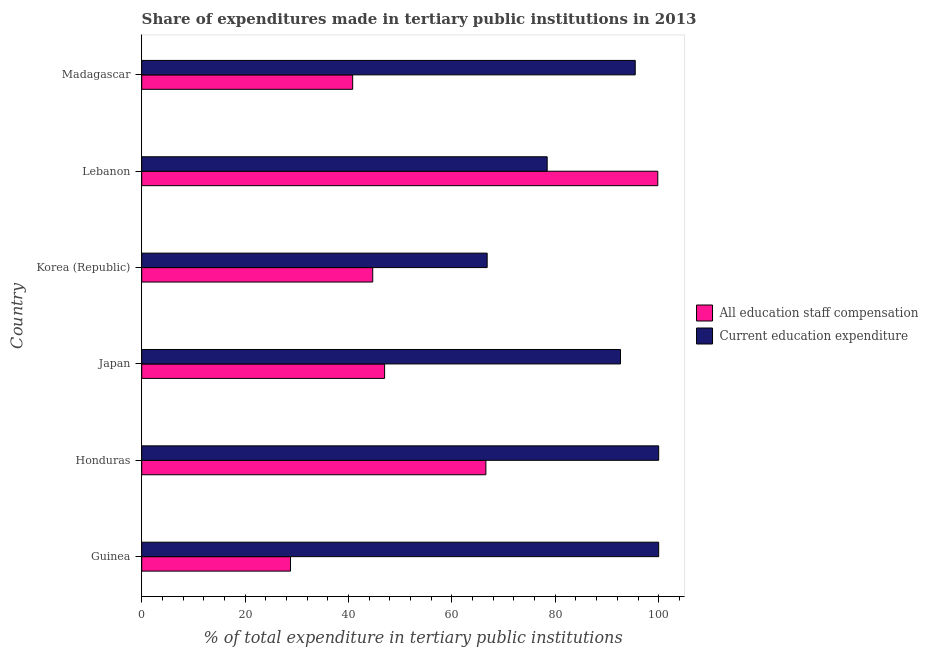How many groups of bars are there?
Offer a terse response. 6. Are the number of bars per tick equal to the number of legend labels?
Provide a succinct answer. Yes. Are the number of bars on each tick of the Y-axis equal?
Provide a short and direct response. Yes. How many bars are there on the 1st tick from the top?
Offer a very short reply. 2. What is the label of the 1st group of bars from the top?
Make the answer very short. Madagascar. In how many cases, is the number of bars for a given country not equal to the number of legend labels?
Your answer should be compact. 0. What is the expenditure in education in Korea (Republic)?
Provide a succinct answer. 66.82. Across all countries, what is the maximum expenditure in staff compensation?
Make the answer very short. 99.83. Across all countries, what is the minimum expenditure in education?
Offer a terse response. 66.82. In which country was the expenditure in education maximum?
Your response must be concise. Guinea. In which country was the expenditure in staff compensation minimum?
Make the answer very short. Guinea. What is the total expenditure in education in the graph?
Give a very brief answer. 533.34. What is the difference between the expenditure in education in Guinea and that in Japan?
Provide a short and direct response. 7.38. What is the difference between the expenditure in education in Madagascar and the expenditure in staff compensation in Guinea?
Provide a succinct answer. 66.68. What is the average expenditure in education per country?
Offer a terse response. 88.89. What is the difference between the expenditure in education and expenditure in staff compensation in Honduras?
Make the answer very short. 33.43. In how many countries, is the expenditure in education greater than 8 %?
Your answer should be compact. 6. What is the ratio of the expenditure in education in Japan to that in Lebanon?
Make the answer very short. 1.18. What is the difference between the highest and the second highest expenditure in education?
Provide a succinct answer. 0. What is the difference between the highest and the lowest expenditure in staff compensation?
Keep it short and to the point. 71.05. Is the sum of the expenditure in staff compensation in Lebanon and Madagascar greater than the maximum expenditure in education across all countries?
Provide a short and direct response. Yes. What does the 2nd bar from the top in Honduras represents?
Offer a terse response. All education staff compensation. What does the 1st bar from the bottom in Madagascar represents?
Your answer should be very brief. All education staff compensation. How many countries are there in the graph?
Offer a very short reply. 6. Does the graph contain grids?
Provide a short and direct response. No. What is the title of the graph?
Offer a terse response. Share of expenditures made in tertiary public institutions in 2013. What is the label or title of the X-axis?
Ensure brevity in your answer.  % of total expenditure in tertiary public institutions. What is the label or title of the Y-axis?
Provide a short and direct response. Country. What is the % of total expenditure in tertiary public institutions in All education staff compensation in Guinea?
Give a very brief answer. 28.78. What is the % of total expenditure in tertiary public institutions in All education staff compensation in Honduras?
Offer a very short reply. 66.57. What is the % of total expenditure in tertiary public institutions of Current education expenditure in Honduras?
Your response must be concise. 100. What is the % of total expenditure in tertiary public institutions in All education staff compensation in Japan?
Offer a terse response. 46.98. What is the % of total expenditure in tertiary public institutions of Current education expenditure in Japan?
Make the answer very short. 92.62. What is the % of total expenditure in tertiary public institutions of All education staff compensation in Korea (Republic)?
Give a very brief answer. 44.69. What is the % of total expenditure in tertiary public institutions of Current education expenditure in Korea (Republic)?
Provide a succinct answer. 66.82. What is the % of total expenditure in tertiary public institutions of All education staff compensation in Lebanon?
Offer a very short reply. 99.83. What is the % of total expenditure in tertiary public institutions of Current education expenditure in Lebanon?
Your answer should be compact. 78.43. What is the % of total expenditure in tertiary public institutions in All education staff compensation in Madagascar?
Your answer should be very brief. 40.81. What is the % of total expenditure in tertiary public institutions in Current education expenditure in Madagascar?
Give a very brief answer. 95.47. Across all countries, what is the maximum % of total expenditure in tertiary public institutions in All education staff compensation?
Ensure brevity in your answer.  99.83. Across all countries, what is the minimum % of total expenditure in tertiary public institutions of All education staff compensation?
Keep it short and to the point. 28.78. Across all countries, what is the minimum % of total expenditure in tertiary public institutions of Current education expenditure?
Keep it short and to the point. 66.82. What is the total % of total expenditure in tertiary public institutions in All education staff compensation in the graph?
Provide a succinct answer. 327.66. What is the total % of total expenditure in tertiary public institutions of Current education expenditure in the graph?
Offer a terse response. 533.34. What is the difference between the % of total expenditure in tertiary public institutions in All education staff compensation in Guinea and that in Honduras?
Provide a short and direct response. -37.79. What is the difference between the % of total expenditure in tertiary public institutions of Current education expenditure in Guinea and that in Honduras?
Offer a very short reply. 0. What is the difference between the % of total expenditure in tertiary public institutions in All education staff compensation in Guinea and that in Japan?
Your response must be concise. -18.2. What is the difference between the % of total expenditure in tertiary public institutions in Current education expenditure in Guinea and that in Japan?
Your answer should be compact. 7.38. What is the difference between the % of total expenditure in tertiary public institutions in All education staff compensation in Guinea and that in Korea (Republic)?
Offer a very short reply. -15.91. What is the difference between the % of total expenditure in tertiary public institutions in Current education expenditure in Guinea and that in Korea (Republic)?
Ensure brevity in your answer.  33.18. What is the difference between the % of total expenditure in tertiary public institutions in All education staff compensation in Guinea and that in Lebanon?
Provide a short and direct response. -71.05. What is the difference between the % of total expenditure in tertiary public institutions of Current education expenditure in Guinea and that in Lebanon?
Keep it short and to the point. 21.57. What is the difference between the % of total expenditure in tertiary public institutions of All education staff compensation in Guinea and that in Madagascar?
Ensure brevity in your answer.  -12.03. What is the difference between the % of total expenditure in tertiary public institutions in Current education expenditure in Guinea and that in Madagascar?
Provide a short and direct response. 4.53. What is the difference between the % of total expenditure in tertiary public institutions of All education staff compensation in Honduras and that in Japan?
Provide a short and direct response. 19.59. What is the difference between the % of total expenditure in tertiary public institutions in Current education expenditure in Honduras and that in Japan?
Your answer should be very brief. 7.38. What is the difference between the % of total expenditure in tertiary public institutions in All education staff compensation in Honduras and that in Korea (Republic)?
Provide a succinct answer. 21.88. What is the difference between the % of total expenditure in tertiary public institutions of Current education expenditure in Honduras and that in Korea (Republic)?
Offer a terse response. 33.18. What is the difference between the % of total expenditure in tertiary public institutions in All education staff compensation in Honduras and that in Lebanon?
Offer a terse response. -33.26. What is the difference between the % of total expenditure in tertiary public institutions of Current education expenditure in Honduras and that in Lebanon?
Your answer should be compact. 21.57. What is the difference between the % of total expenditure in tertiary public institutions of All education staff compensation in Honduras and that in Madagascar?
Make the answer very short. 25.76. What is the difference between the % of total expenditure in tertiary public institutions in Current education expenditure in Honduras and that in Madagascar?
Make the answer very short. 4.53. What is the difference between the % of total expenditure in tertiary public institutions of All education staff compensation in Japan and that in Korea (Republic)?
Offer a terse response. 2.3. What is the difference between the % of total expenditure in tertiary public institutions of Current education expenditure in Japan and that in Korea (Republic)?
Give a very brief answer. 25.79. What is the difference between the % of total expenditure in tertiary public institutions of All education staff compensation in Japan and that in Lebanon?
Your answer should be very brief. -52.85. What is the difference between the % of total expenditure in tertiary public institutions in Current education expenditure in Japan and that in Lebanon?
Offer a terse response. 14.18. What is the difference between the % of total expenditure in tertiary public institutions of All education staff compensation in Japan and that in Madagascar?
Offer a very short reply. 6.18. What is the difference between the % of total expenditure in tertiary public institutions in Current education expenditure in Japan and that in Madagascar?
Give a very brief answer. -2.85. What is the difference between the % of total expenditure in tertiary public institutions in All education staff compensation in Korea (Republic) and that in Lebanon?
Offer a very short reply. -55.14. What is the difference between the % of total expenditure in tertiary public institutions of Current education expenditure in Korea (Republic) and that in Lebanon?
Ensure brevity in your answer.  -11.61. What is the difference between the % of total expenditure in tertiary public institutions of All education staff compensation in Korea (Republic) and that in Madagascar?
Ensure brevity in your answer.  3.88. What is the difference between the % of total expenditure in tertiary public institutions of Current education expenditure in Korea (Republic) and that in Madagascar?
Provide a short and direct response. -28.64. What is the difference between the % of total expenditure in tertiary public institutions of All education staff compensation in Lebanon and that in Madagascar?
Offer a terse response. 59.02. What is the difference between the % of total expenditure in tertiary public institutions in Current education expenditure in Lebanon and that in Madagascar?
Provide a succinct answer. -17.03. What is the difference between the % of total expenditure in tertiary public institutions of All education staff compensation in Guinea and the % of total expenditure in tertiary public institutions of Current education expenditure in Honduras?
Your response must be concise. -71.22. What is the difference between the % of total expenditure in tertiary public institutions of All education staff compensation in Guinea and the % of total expenditure in tertiary public institutions of Current education expenditure in Japan?
Your answer should be very brief. -63.83. What is the difference between the % of total expenditure in tertiary public institutions in All education staff compensation in Guinea and the % of total expenditure in tertiary public institutions in Current education expenditure in Korea (Republic)?
Your answer should be very brief. -38.04. What is the difference between the % of total expenditure in tertiary public institutions of All education staff compensation in Guinea and the % of total expenditure in tertiary public institutions of Current education expenditure in Lebanon?
Ensure brevity in your answer.  -49.65. What is the difference between the % of total expenditure in tertiary public institutions in All education staff compensation in Guinea and the % of total expenditure in tertiary public institutions in Current education expenditure in Madagascar?
Offer a terse response. -66.68. What is the difference between the % of total expenditure in tertiary public institutions of All education staff compensation in Honduras and the % of total expenditure in tertiary public institutions of Current education expenditure in Japan?
Offer a very short reply. -26.04. What is the difference between the % of total expenditure in tertiary public institutions of All education staff compensation in Honduras and the % of total expenditure in tertiary public institutions of Current education expenditure in Korea (Republic)?
Make the answer very short. -0.25. What is the difference between the % of total expenditure in tertiary public institutions in All education staff compensation in Honduras and the % of total expenditure in tertiary public institutions in Current education expenditure in Lebanon?
Provide a short and direct response. -11.86. What is the difference between the % of total expenditure in tertiary public institutions in All education staff compensation in Honduras and the % of total expenditure in tertiary public institutions in Current education expenditure in Madagascar?
Your answer should be compact. -28.89. What is the difference between the % of total expenditure in tertiary public institutions of All education staff compensation in Japan and the % of total expenditure in tertiary public institutions of Current education expenditure in Korea (Republic)?
Make the answer very short. -19.84. What is the difference between the % of total expenditure in tertiary public institutions of All education staff compensation in Japan and the % of total expenditure in tertiary public institutions of Current education expenditure in Lebanon?
Offer a terse response. -31.45. What is the difference between the % of total expenditure in tertiary public institutions in All education staff compensation in Japan and the % of total expenditure in tertiary public institutions in Current education expenditure in Madagascar?
Keep it short and to the point. -48.48. What is the difference between the % of total expenditure in tertiary public institutions of All education staff compensation in Korea (Republic) and the % of total expenditure in tertiary public institutions of Current education expenditure in Lebanon?
Ensure brevity in your answer.  -33.74. What is the difference between the % of total expenditure in tertiary public institutions in All education staff compensation in Korea (Republic) and the % of total expenditure in tertiary public institutions in Current education expenditure in Madagascar?
Offer a terse response. -50.78. What is the difference between the % of total expenditure in tertiary public institutions in All education staff compensation in Lebanon and the % of total expenditure in tertiary public institutions in Current education expenditure in Madagascar?
Keep it short and to the point. 4.37. What is the average % of total expenditure in tertiary public institutions in All education staff compensation per country?
Make the answer very short. 54.61. What is the average % of total expenditure in tertiary public institutions in Current education expenditure per country?
Keep it short and to the point. 88.89. What is the difference between the % of total expenditure in tertiary public institutions of All education staff compensation and % of total expenditure in tertiary public institutions of Current education expenditure in Guinea?
Provide a succinct answer. -71.22. What is the difference between the % of total expenditure in tertiary public institutions of All education staff compensation and % of total expenditure in tertiary public institutions of Current education expenditure in Honduras?
Offer a very short reply. -33.43. What is the difference between the % of total expenditure in tertiary public institutions in All education staff compensation and % of total expenditure in tertiary public institutions in Current education expenditure in Japan?
Offer a terse response. -45.63. What is the difference between the % of total expenditure in tertiary public institutions of All education staff compensation and % of total expenditure in tertiary public institutions of Current education expenditure in Korea (Republic)?
Make the answer very short. -22.14. What is the difference between the % of total expenditure in tertiary public institutions in All education staff compensation and % of total expenditure in tertiary public institutions in Current education expenditure in Lebanon?
Your response must be concise. 21.4. What is the difference between the % of total expenditure in tertiary public institutions of All education staff compensation and % of total expenditure in tertiary public institutions of Current education expenditure in Madagascar?
Your answer should be compact. -54.66. What is the ratio of the % of total expenditure in tertiary public institutions in All education staff compensation in Guinea to that in Honduras?
Offer a terse response. 0.43. What is the ratio of the % of total expenditure in tertiary public institutions in All education staff compensation in Guinea to that in Japan?
Your answer should be very brief. 0.61. What is the ratio of the % of total expenditure in tertiary public institutions of Current education expenditure in Guinea to that in Japan?
Make the answer very short. 1.08. What is the ratio of the % of total expenditure in tertiary public institutions of All education staff compensation in Guinea to that in Korea (Republic)?
Ensure brevity in your answer.  0.64. What is the ratio of the % of total expenditure in tertiary public institutions of Current education expenditure in Guinea to that in Korea (Republic)?
Make the answer very short. 1.5. What is the ratio of the % of total expenditure in tertiary public institutions in All education staff compensation in Guinea to that in Lebanon?
Your answer should be very brief. 0.29. What is the ratio of the % of total expenditure in tertiary public institutions in Current education expenditure in Guinea to that in Lebanon?
Provide a succinct answer. 1.27. What is the ratio of the % of total expenditure in tertiary public institutions in All education staff compensation in Guinea to that in Madagascar?
Keep it short and to the point. 0.71. What is the ratio of the % of total expenditure in tertiary public institutions of Current education expenditure in Guinea to that in Madagascar?
Keep it short and to the point. 1.05. What is the ratio of the % of total expenditure in tertiary public institutions of All education staff compensation in Honduras to that in Japan?
Ensure brevity in your answer.  1.42. What is the ratio of the % of total expenditure in tertiary public institutions in Current education expenditure in Honduras to that in Japan?
Your response must be concise. 1.08. What is the ratio of the % of total expenditure in tertiary public institutions in All education staff compensation in Honduras to that in Korea (Republic)?
Give a very brief answer. 1.49. What is the ratio of the % of total expenditure in tertiary public institutions in Current education expenditure in Honduras to that in Korea (Republic)?
Your answer should be compact. 1.5. What is the ratio of the % of total expenditure in tertiary public institutions of All education staff compensation in Honduras to that in Lebanon?
Your response must be concise. 0.67. What is the ratio of the % of total expenditure in tertiary public institutions of Current education expenditure in Honduras to that in Lebanon?
Give a very brief answer. 1.27. What is the ratio of the % of total expenditure in tertiary public institutions of All education staff compensation in Honduras to that in Madagascar?
Your response must be concise. 1.63. What is the ratio of the % of total expenditure in tertiary public institutions in Current education expenditure in Honduras to that in Madagascar?
Offer a very short reply. 1.05. What is the ratio of the % of total expenditure in tertiary public institutions in All education staff compensation in Japan to that in Korea (Republic)?
Make the answer very short. 1.05. What is the ratio of the % of total expenditure in tertiary public institutions in Current education expenditure in Japan to that in Korea (Republic)?
Your answer should be compact. 1.39. What is the ratio of the % of total expenditure in tertiary public institutions in All education staff compensation in Japan to that in Lebanon?
Give a very brief answer. 0.47. What is the ratio of the % of total expenditure in tertiary public institutions in Current education expenditure in Japan to that in Lebanon?
Give a very brief answer. 1.18. What is the ratio of the % of total expenditure in tertiary public institutions in All education staff compensation in Japan to that in Madagascar?
Keep it short and to the point. 1.15. What is the ratio of the % of total expenditure in tertiary public institutions of Current education expenditure in Japan to that in Madagascar?
Offer a terse response. 0.97. What is the ratio of the % of total expenditure in tertiary public institutions of All education staff compensation in Korea (Republic) to that in Lebanon?
Provide a succinct answer. 0.45. What is the ratio of the % of total expenditure in tertiary public institutions of Current education expenditure in Korea (Republic) to that in Lebanon?
Offer a very short reply. 0.85. What is the ratio of the % of total expenditure in tertiary public institutions of All education staff compensation in Korea (Republic) to that in Madagascar?
Offer a very short reply. 1.1. What is the ratio of the % of total expenditure in tertiary public institutions in All education staff compensation in Lebanon to that in Madagascar?
Provide a succinct answer. 2.45. What is the ratio of the % of total expenditure in tertiary public institutions in Current education expenditure in Lebanon to that in Madagascar?
Make the answer very short. 0.82. What is the difference between the highest and the second highest % of total expenditure in tertiary public institutions of All education staff compensation?
Provide a short and direct response. 33.26. What is the difference between the highest and the second highest % of total expenditure in tertiary public institutions in Current education expenditure?
Give a very brief answer. 0. What is the difference between the highest and the lowest % of total expenditure in tertiary public institutions in All education staff compensation?
Make the answer very short. 71.05. What is the difference between the highest and the lowest % of total expenditure in tertiary public institutions of Current education expenditure?
Give a very brief answer. 33.18. 